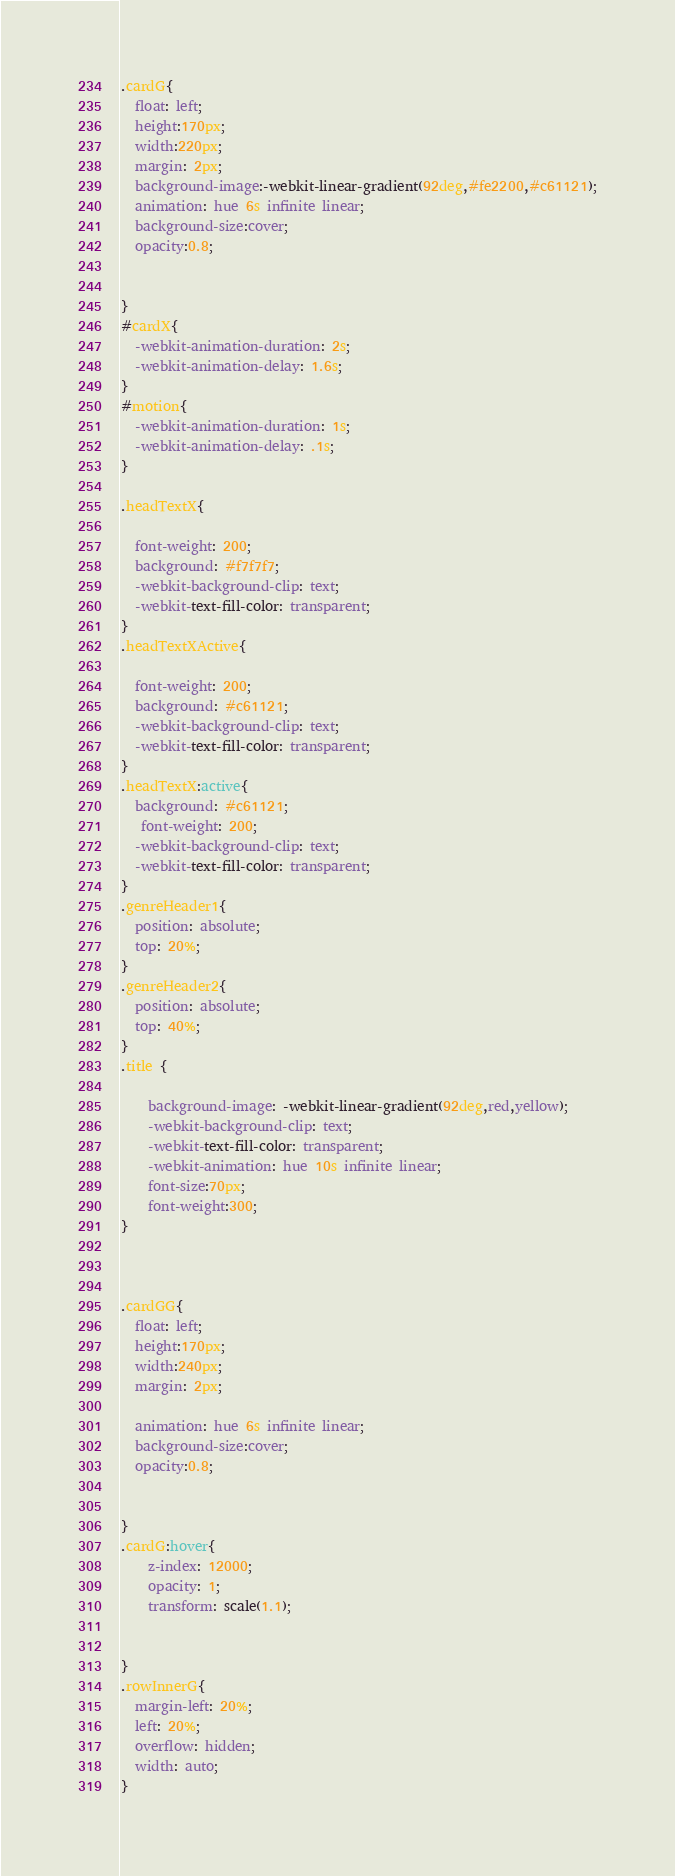<code> <loc_0><loc_0><loc_500><loc_500><_CSS_>.cardG{
  float: left;
  height:170px;
  width:220px;
  margin: 2px;
  background-image:-webkit-linear-gradient(92deg,#fe2200,#c61121);
  animation: hue 6s infinite linear;
  background-size:cover;
  opacity:0.8;
  
  
}
#cardX{
  -webkit-animation-duration: 2s;
  -webkit-animation-delay: 1.6s;
}
#motion{
  -webkit-animation-duration: 1s;
  -webkit-animation-delay: .1s;
}

.headTextX{

  font-weight: 200;
  background: #f7f7f7;
  -webkit-background-clip: text;
  -webkit-text-fill-color: transparent;
}
.headTextXActive{

  font-weight: 200;
  background: #c61121;
  -webkit-background-clip: text;
  -webkit-text-fill-color: transparent;
}
.headTextX:active{
  background: #c61121;
   font-weight: 200;
  -webkit-background-clip: text;
  -webkit-text-fill-color: transparent;
}
.genreHeader1{
  position: absolute;
  top: 20%; 
}
.genreHeader2{
  position: absolute;
  top: 40%; 
}
.title {
	
	background-image: -webkit-linear-gradient(92deg,red,yellow);
	-webkit-background-clip: text;
	-webkit-text-fill-color: transparent;
	-webkit-animation: hue 10s infinite linear;
	font-size:70px;
	font-weight:300;
}



.cardGG{
  float: left;
  height:170px;
  width:240px;
  margin: 2px;
  
  animation: hue 6s infinite linear;
  background-size:cover;
  opacity:0.8;
  
  
}
.cardG:hover{
	z-index: 12000;
	opacity: 1;
	transform: scale(1.1);
	

}
.rowInnerG{
  margin-left: 20%;
  left: 20%;
  overflow: hidden;
  width: auto;
}</code> 